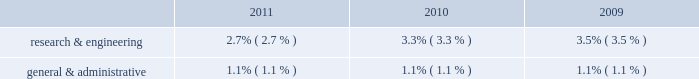Equity in net earnings of affiliated companies equity income from the m-i swaco joint venture in 2010 represents eight months of equity income through the closing of the smith transaction .
Interest expense interest expense of $ 298 million in 2011 increased by $ 91 million compared to 2010 primarily due to the $ 4.6 billion of long-term debt that schlumberger issued during 2011 .
Interest expense of $ 207 million in 2010 decreased by $ 14 million compared to 2009 primarily due to a decline in the weighted average borrowing rates , from 3.9% ( 3.9 % ) to 3.2% ( 3.2 % ) .
Research & engineering and general & administrative expenses , as a percentage of revenue , were as follows: .
Although research & engineering decreased as a percentage of revenue in 2011 as compared to 2010 and in 2010 compared to 2009 , it has increased in absolute dollars by $ 154 million and $ 117 million , respectively .
These increases in absolute dollars were driven in large part by the impact of the smith acquisition .
Income taxes the schlumberger effective tax rate was 24.4% ( 24.4 % ) in 2011 , 17.3% ( 17.3 % ) in 2010 , and 19.6% ( 19.6 % ) in 2009 .
The schlumberger effective tax rate is sensitive to the geographic mix of earnings .
When the percentage of pretax earnings generated outside of north america increases , the schlumberger effective tax rate will generally decrease .
Conversely , when the percentage of pretax earnings generated outside of north america decreases , the schlumberger effective tax rate will generally increase .
The effective tax rate for both 2011 and 2010 was impacted by the charges and credits described in note 3 to the consolidated financial statements .
Excluding the impact of these charges and credits , the effective tax rate in 2011 was 24.0% ( 24.0 % ) compared to 20.6% ( 20.6 % ) in 2010 .
This increase in the effective tax rate , excluding the impact of the charges and credits , was primarily attributable to the fact that schlumberger generated a larger proportion of its pretax earnings in north america in 2011 as compared to 2010 as a result of improved market conditions and the effect of a full year 2019s activity from the acquired smith businesses .
The effective tax rate for 2009 was also impacted by the charges and credits described in note 3 to the consolidated financial statements , but to a much lesser extent .
Excluding charges and credits , the effective tax rate in 2010 was 20.6% ( 20.6 % ) compared to 19.2% ( 19.2 % ) in 2009 .
This increase is largely attributable to the geographic mix of earnings as well as the inclusion of four months 2019 results from the acquisition of smith , which served to increase the schlumberger effective tax charges and credits schlumberger recorded significant charges and credits in continuing operations during 2011 , 2010 and 2009 .
These charges and credits , which are summarized below , are more fully described in note 3 to the consolidated financial statements. .
What was the growth rate of the schlumberger interest expense from 2010 to 2011? 
Computations: (91 / (298 - 91))
Answer: 0.43961. Equity in net earnings of affiliated companies equity income from the m-i swaco joint venture in 2010 represents eight months of equity income through the closing of the smith transaction .
Interest expense interest expense of $ 298 million in 2011 increased by $ 91 million compared to 2010 primarily due to the $ 4.6 billion of long-term debt that schlumberger issued during 2011 .
Interest expense of $ 207 million in 2010 decreased by $ 14 million compared to 2009 primarily due to a decline in the weighted average borrowing rates , from 3.9% ( 3.9 % ) to 3.2% ( 3.2 % ) .
Research & engineering and general & administrative expenses , as a percentage of revenue , were as follows: .
Although research & engineering decreased as a percentage of revenue in 2011 as compared to 2010 and in 2010 compared to 2009 , it has increased in absolute dollars by $ 154 million and $ 117 million , respectively .
These increases in absolute dollars were driven in large part by the impact of the smith acquisition .
Income taxes the schlumberger effective tax rate was 24.4% ( 24.4 % ) in 2011 , 17.3% ( 17.3 % ) in 2010 , and 19.6% ( 19.6 % ) in 2009 .
The schlumberger effective tax rate is sensitive to the geographic mix of earnings .
When the percentage of pretax earnings generated outside of north america increases , the schlumberger effective tax rate will generally decrease .
Conversely , when the percentage of pretax earnings generated outside of north america decreases , the schlumberger effective tax rate will generally increase .
The effective tax rate for both 2011 and 2010 was impacted by the charges and credits described in note 3 to the consolidated financial statements .
Excluding the impact of these charges and credits , the effective tax rate in 2011 was 24.0% ( 24.0 % ) compared to 20.6% ( 20.6 % ) in 2010 .
This increase in the effective tax rate , excluding the impact of the charges and credits , was primarily attributable to the fact that schlumberger generated a larger proportion of its pretax earnings in north america in 2011 as compared to 2010 as a result of improved market conditions and the effect of a full year 2019s activity from the acquired smith businesses .
The effective tax rate for 2009 was also impacted by the charges and credits described in note 3 to the consolidated financial statements , but to a much lesser extent .
Excluding charges and credits , the effective tax rate in 2010 was 20.6% ( 20.6 % ) compared to 19.2% ( 19.2 % ) in 2009 .
This increase is largely attributable to the geographic mix of earnings as well as the inclusion of four months 2019 results from the acquisition of smith , which served to increase the schlumberger effective tax charges and credits schlumberger recorded significant charges and credits in continuing operations during 2011 , 2010 and 2009 .
These charges and credits , which are summarized below , are more fully described in note 3 to the consolidated financial statements. .
What was the percent growth or decline of research & engineering as a percent of revenue from 2010 to 2011? 
Rationale: the growth rate is the difference in amounts from one period to another divided by the initial period
Computations: ((2.7 - 3.3) / 3.3)
Answer: -0.18182. 